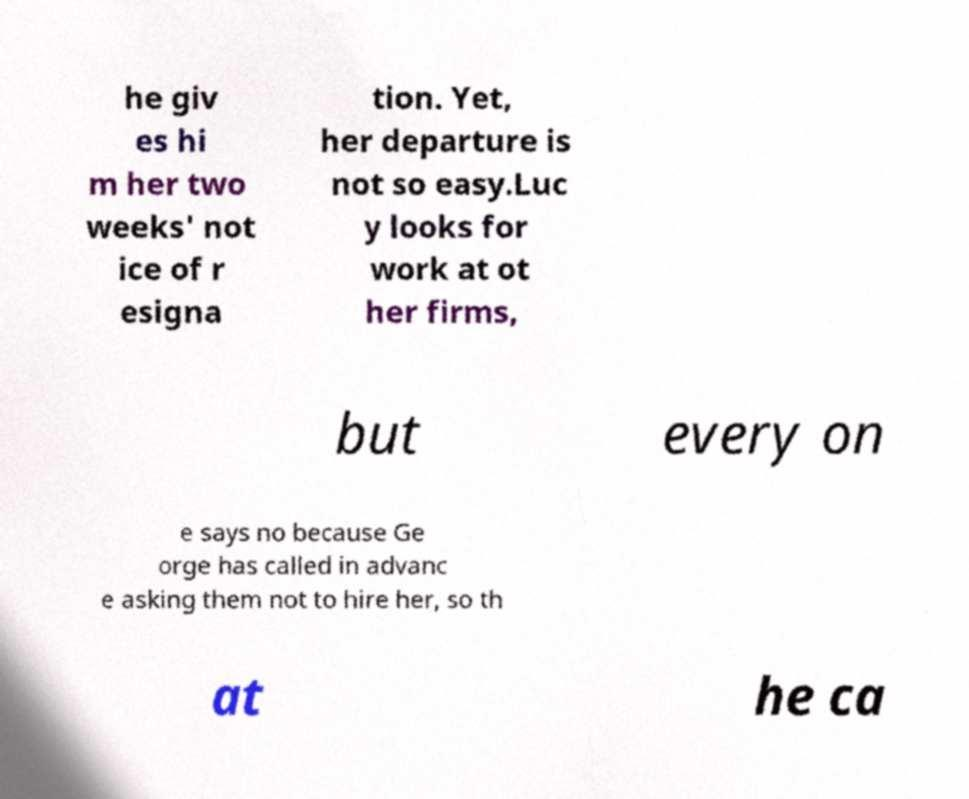Could you assist in decoding the text presented in this image and type it out clearly? he giv es hi m her two weeks' not ice of r esigna tion. Yet, her departure is not so easy.Luc y looks for work at ot her firms, but every on e says no because Ge orge has called in advanc e asking them not to hire her, so th at he ca 